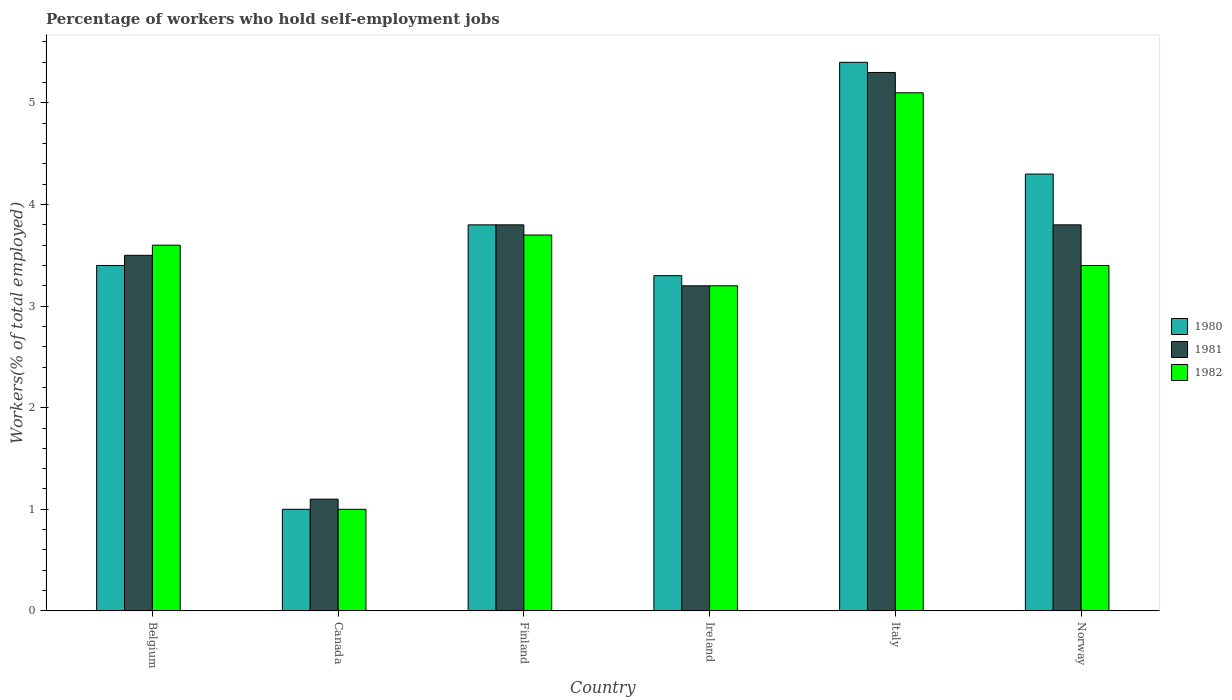How many groups of bars are there?
Ensure brevity in your answer.  6. Are the number of bars on each tick of the X-axis equal?
Your response must be concise. Yes. How many bars are there on the 2nd tick from the left?
Make the answer very short. 3. In how many cases, is the number of bars for a given country not equal to the number of legend labels?
Provide a short and direct response. 0. What is the percentage of self-employed workers in 1980 in Ireland?
Provide a short and direct response. 3.3. Across all countries, what is the maximum percentage of self-employed workers in 1980?
Offer a very short reply. 5.4. Across all countries, what is the minimum percentage of self-employed workers in 1982?
Provide a succinct answer. 1. In which country was the percentage of self-employed workers in 1980 minimum?
Make the answer very short. Canada. What is the total percentage of self-employed workers in 1980 in the graph?
Ensure brevity in your answer.  21.2. What is the difference between the percentage of self-employed workers in 1980 in Canada and that in Ireland?
Provide a succinct answer. -2.3. What is the difference between the percentage of self-employed workers in 1981 in Italy and the percentage of self-employed workers in 1982 in Ireland?
Your answer should be very brief. 2.1. What is the average percentage of self-employed workers in 1981 per country?
Provide a short and direct response. 3.45. What is the ratio of the percentage of self-employed workers in 1980 in Belgium to that in Italy?
Your answer should be very brief. 0.63. What is the difference between the highest and the second highest percentage of self-employed workers in 1982?
Make the answer very short. -0.1. What is the difference between the highest and the lowest percentage of self-employed workers in 1981?
Offer a very short reply. 4.2. In how many countries, is the percentage of self-employed workers in 1980 greater than the average percentage of self-employed workers in 1980 taken over all countries?
Make the answer very short. 3. Is the sum of the percentage of self-employed workers in 1982 in Canada and Finland greater than the maximum percentage of self-employed workers in 1981 across all countries?
Offer a very short reply. No. What does the 2nd bar from the left in Norway represents?
Your answer should be compact. 1981. What is the difference between two consecutive major ticks on the Y-axis?
Provide a succinct answer. 1. Does the graph contain any zero values?
Offer a very short reply. No. What is the title of the graph?
Offer a very short reply. Percentage of workers who hold self-employment jobs. Does "1982" appear as one of the legend labels in the graph?
Keep it short and to the point. Yes. What is the label or title of the X-axis?
Offer a very short reply. Country. What is the label or title of the Y-axis?
Offer a terse response. Workers(% of total employed). What is the Workers(% of total employed) in 1980 in Belgium?
Offer a terse response. 3.4. What is the Workers(% of total employed) of 1982 in Belgium?
Your response must be concise. 3.6. What is the Workers(% of total employed) in 1980 in Canada?
Provide a short and direct response. 1. What is the Workers(% of total employed) in 1981 in Canada?
Provide a succinct answer. 1.1. What is the Workers(% of total employed) in 1980 in Finland?
Provide a short and direct response. 3.8. What is the Workers(% of total employed) of 1981 in Finland?
Make the answer very short. 3.8. What is the Workers(% of total employed) of 1982 in Finland?
Provide a short and direct response. 3.7. What is the Workers(% of total employed) in 1980 in Ireland?
Ensure brevity in your answer.  3.3. What is the Workers(% of total employed) in 1981 in Ireland?
Keep it short and to the point. 3.2. What is the Workers(% of total employed) of 1982 in Ireland?
Your answer should be compact. 3.2. What is the Workers(% of total employed) of 1980 in Italy?
Keep it short and to the point. 5.4. What is the Workers(% of total employed) in 1981 in Italy?
Keep it short and to the point. 5.3. What is the Workers(% of total employed) of 1982 in Italy?
Your answer should be very brief. 5.1. What is the Workers(% of total employed) in 1980 in Norway?
Ensure brevity in your answer.  4.3. What is the Workers(% of total employed) of 1981 in Norway?
Your answer should be very brief. 3.8. What is the Workers(% of total employed) of 1982 in Norway?
Offer a very short reply. 3.4. Across all countries, what is the maximum Workers(% of total employed) of 1980?
Offer a very short reply. 5.4. Across all countries, what is the maximum Workers(% of total employed) in 1981?
Offer a very short reply. 5.3. Across all countries, what is the maximum Workers(% of total employed) in 1982?
Ensure brevity in your answer.  5.1. Across all countries, what is the minimum Workers(% of total employed) in 1981?
Provide a succinct answer. 1.1. Across all countries, what is the minimum Workers(% of total employed) in 1982?
Provide a short and direct response. 1. What is the total Workers(% of total employed) in 1980 in the graph?
Keep it short and to the point. 21.2. What is the total Workers(% of total employed) of 1981 in the graph?
Your response must be concise. 20.7. What is the difference between the Workers(% of total employed) of 1981 in Belgium and that in Finland?
Provide a succinct answer. -0.3. What is the difference between the Workers(% of total employed) in 1982 in Belgium and that in Finland?
Offer a terse response. -0.1. What is the difference between the Workers(% of total employed) in 1980 in Belgium and that in Ireland?
Provide a short and direct response. 0.1. What is the difference between the Workers(% of total employed) of 1981 in Belgium and that in Ireland?
Make the answer very short. 0.3. What is the difference between the Workers(% of total employed) in 1981 in Belgium and that in Italy?
Offer a very short reply. -1.8. What is the difference between the Workers(% of total employed) of 1982 in Belgium and that in Italy?
Provide a succinct answer. -1.5. What is the difference between the Workers(% of total employed) in 1980 in Belgium and that in Norway?
Offer a very short reply. -0.9. What is the difference between the Workers(% of total employed) in 1982 in Belgium and that in Norway?
Offer a terse response. 0.2. What is the difference between the Workers(% of total employed) in 1981 in Canada and that in Finland?
Keep it short and to the point. -2.7. What is the difference between the Workers(% of total employed) in 1982 in Canada and that in Finland?
Ensure brevity in your answer.  -2.7. What is the difference between the Workers(% of total employed) of 1980 in Canada and that in Ireland?
Provide a short and direct response. -2.3. What is the difference between the Workers(% of total employed) in 1981 in Canada and that in Ireland?
Your response must be concise. -2.1. What is the difference between the Workers(% of total employed) of 1981 in Canada and that in Italy?
Provide a succinct answer. -4.2. What is the difference between the Workers(% of total employed) in 1982 in Canada and that in Italy?
Your response must be concise. -4.1. What is the difference between the Workers(% of total employed) of 1981 in Canada and that in Norway?
Your answer should be compact. -2.7. What is the difference between the Workers(% of total employed) of 1982 in Canada and that in Norway?
Your answer should be very brief. -2.4. What is the difference between the Workers(% of total employed) in 1980 in Finland and that in Ireland?
Your response must be concise. 0.5. What is the difference between the Workers(% of total employed) in 1981 in Finland and that in Ireland?
Your answer should be compact. 0.6. What is the difference between the Workers(% of total employed) in 1982 in Finland and that in Ireland?
Make the answer very short. 0.5. What is the difference between the Workers(% of total employed) in 1982 in Finland and that in Italy?
Provide a succinct answer. -1.4. What is the difference between the Workers(% of total employed) of 1980 in Ireland and that in Norway?
Your answer should be compact. -1. What is the difference between the Workers(% of total employed) in 1981 in Ireland and that in Norway?
Keep it short and to the point. -0.6. What is the difference between the Workers(% of total employed) in 1982 in Italy and that in Norway?
Give a very brief answer. 1.7. What is the difference between the Workers(% of total employed) in 1981 in Belgium and the Workers(% of total employed) in 1982 in Canada?
Provide a succinct answer. 2.5. What is the difference between the Workers(% of total employed) of 1980 in Belgium and the Workers(% of total employed) of 1981 in Finland?
Ensure brevity in your answer.  -0.4. What is the difference between the Workers(% of total employed) in 1981 in Belgium and the Workers(% of total employed) in 1982 in Finland?
Your answer should be very brief. -0.2. What is the difference between the Workers(% of total employed) in 1980 in Belgium and the Workers(% of total employed) in 1981 in Ireland?
Offer a very short reply. 0.2. What is the difference between the Workers(% of total employed) of 1980 in Belgium and the Workers(% of total employed) of 1982 in Italy?
Keep it short and to the point. -1.7. What is the difference between the Workers(% of total employed) in 1980 in Belgium and the Workers(% of total employed) in 1982 in Norway?
Provide a short and direct response. 0. What is the difference between the Workers(% of total employed) in 1981 in Belgium and the Workers(% of total employed) in 1982 in Norway?
Your answer should be compact. 0.1. What is the difference between the Workers(% of total employed) of 1980 in Canada and the Workers(% of total employed) of 1981 in Finland?
Keep it short and to the point. -2.8. What is the difference between the Workers(% of total employed) of 1981 in Canada and the Workers(% of total employed) of 1982 in Ireland?
Keep it short and to the point. -2.1. What is the difference between the Workers(% of total employed) of 1980 in Canada and the Workers(% of total employed) of 1981 in Italy?
Provide a short and direct response. -4.3. What is the difference between the Workers(% of total employed) of 1980 in Canada and the Workers(% of total employed) of 1982 in Italy?
Offer a very short reply. -4.1. What is the difference between the Workers(% of total employed) in 1981 in Canada and the Workers(% of total employed) in 1982 in Italy?
Offer a very short reply. -4. What is the difference between the Workers(% of total employed) in 1980 in Canada and the Workers(% of total employed) in 1981 in Norway?
Your answer should be compact. -2.8. What is the difference between the Workers(% of total employed) in 1981 in Canada and the Workers(% of total employed) in 1982 in Norway?
Offer a terse response. -2.3. What is the difference between the Workers(% of total employed) in 1981 in Finland and the Workers(% of total employed) in 1982 in Ireland?
Your response must be concise. 0.6. What is the difference between the Workers(% of total employed) of 1980 in Finland and the Workers(% of total employed) of 1981 in Italy?
Your answer should be very brief. -1.5. What is the difference between the Workers(% of total employed) of 1980 in Finland and the Workers(% of total employed) of 1982 in Italy?
Keep it short and to the point. -1.3. What is the difference between the Workers(% of total employed) in 1981 in Finland and the Workers(% of total employed) in 1982 in Italy?
Provide a succinct answer. -1.3. What is the difference between the Workers(% of total employed) of 1980 in Finland and the Workers(% of total employed) of 1981 in Norway?
Provide a short and direct response. 0. What is the difference between the Workers(% of total employed) of 1980 in Finland and the Workers(% of total employed) of 1982 in Norway?
Your answer should be compact. 0.4. What is the difference between the Workers(% of total employed) of 1980 in Ireland and the Workers(% of total employed) of 1981 in Italy?
Offer a terse response. -2. What is the difference between the Workers(% of total employed) in 1980 in Ireland and the Workers(% of total employed) in 1981 in Norway?
Provide a succinct answer. -0.5. What is the difference between the Workers(% of total employed) in 1980 in Ireland and the Workers(% of total employed) in 1982 in Norway?
Offer a terse response. -0.1. What is the difference between the Workers(% of total employed) in 1980 in Italy and the Workers(% of total employed) in 1981 in Norway?
Provide a short and direct response. 1.6. What is the difference between the Workers(% of total employed) in 1980 in Italy and the Workers(% of total employed) in 1982 in Norway?
Your response must be concise. 2. What is the difference between the Workers(% of total employed) of 1981 in Italy and the Workers(% of total employed) of 1982 in Norway?
Offer a very short reply. 1.9. What is the average Workers(% of total employed) in 1980 per country?
Provide a succinct answer. 3.53. What is the average Workers(% of total employed) in 1981 per country?
Make the answer very short. 3.45. What is the average Workers(% of total employed) of 1982 per country?
Offer a very short reply. 3.33. What is the difference between the Workers(% of total employed) in 1980 and Workers(% of total employed) in 1981 in Belgium?
Offer a terse response. -0.1. What is the difference between the Workers(% of total employed) of 1980 and Workers(% of total employed) of 1982 in Belgium?
Provide a short and direct response. -0.2. What is the difference between the Workers(% of total employed) of 1980 and Workers(% of total employed) of 1981 in Canada?
Provide a short and direct response. -0.1. What is the difference between the Workers(% of total employed) of 1981 and Workers(% of total employed) of 1982 in Canada?
Your response must be concise. 0.1. What is the difference between the Workers(% of total employed) in 1980 and Workers(% of total employed) in 1982 in Finland?
Your answer should be very brief. 0.1. What is the difference between the Workers(% of total employed) in 1981 and Workers(% of total employed) in 1982 in Finland?
Ensure brevity in your answer.  0.1. What is the difference between the Workers(% of total employed) of 1980 and Workers(% of total employed) of 1982 in Ireland?
Your answer should be compact. 0.1. What is the difference between the Workers(% of total employed) of 1981 and Workers(% of total employed) of 1982 in Ireland?
Your answer should be very brief. 0. What is the difference between the Workers(% of total employed) of 1980 and Workers(% of total employed) of 1981 in Italy?
Your answer should be compact. 0.1. What is the difference between the Workers(% of total employed) in 1980 and Workers(% of total employed) in 1981 in Norway?
Your answer should be compact. 0.5. What is the ratio of the Workers(% of total employed) in 1980 in Belgium to that in Canada?
Make the answer very short. 3.4. What is the ratio of the Workers(% of total employed) in 1981 in Belgium to that in Canada?
Provide a succinct answer. 3.18. What is the ratio of the Workers(% of total employed) of 1980 in Belgium to that in Finland?
Provide a succinct answer. 0.89. What is the ratio of the Workers(% of total employed) of 1981 in Belgium to that in Finland?
Ensure brevity in your answer.  0.92. What is the ratio of the Workers(% of total employed) in 1982 in Belgium to that in Finland?
Offer a terse response. 0.97. What is the ratio of the Workers(% of total employed) of 1980 in Belgium to that in Ireland?
Keep it short and to the point. 1.03. What is the ratio of the Workers(% of total employed) in 1981 in Belgium to that in Ireland?
Keep it short and to the point. 1.09. What is the ratio of the Workers(% of total employed) in 1982 in Belgium to that in Ireland?
Your response must be concise. 1.12. What is the ratio of the Workers(% of total employed) of 1980 in Belgium to that in Italy?
Make the answer very short. 0.63. What is the ratio of the Workers(% of total employed) of 1981 in Belgium to that in Italy?
Make the answer very short. 0.66. What is the ratio of the Workers(% of total employed) in 1982 in Belgium to that in Italy?
Provide a short and direct response. 0.71. What is the ratio of the Workers(% of total employed) of 1980 in Belgium to that in Norway?
Offer a terse response. 0.79. What is the ratio of the Workers(% of total employed) of 1981 in Belgium to that in Norway?
Provide a short and direct response. 0.92. What is the ratio of the Workers(% of total employed) of 1982 in Belgium to that in Norway?
Provide a short and direct response. 1.06. What is the ratio of the Workers(% of total employed) in 1980 in Canada to that in Finland?
Your response must be concise. 0.26. What is the ratio of the Workers(% of total employed) of 1981 in Canada to that in Finland?
Ensure brevity in your answer.  0.29. What is the ratio of the Workers(% of total employed) of 1982 in Canada to that in Finland?
Your response must be concise. 0.27. What is the ratio of the Workers(% of total employed) in 1980 in Canada to that in Ireland?
Offer a terse response. 0.3. What is the ratio of the Workers(% of total employed) of 1981 in Canada to that in Ireland?
Your response must be concise. 0.34. What is the ratio of the Workers(% of total employed) of 1982 in Canada to that in Ireland?
Ensure brevity in your answer.  0.31. What is the ratio of the Workers(% of total employed) of 1980 in Canada to that in Italy?
Ensure brevity in your answer.  0.19. What is the ratio of the Workers(% of total employed) of 1981 in Canada to that in Italy?
Offer a very short reply. 0.21. What is the ratio of the Workers(% of total employed) of 1982 in Canada to that in Italy?
Your answer should be compact. 0.2. What is the ratio of the Workers(% of total employed) in 1980 in Canada to that in Norway?
Offer a terse response. 0.23. What is the ratio of the Workers(% of total employed) in 1981 in Canada to that in Norway?
Your response must be concise. 0.29. What is the ratio of the Workers(% of total employed) in 1982 in Canada to that in Norway?
Provide a succinct answer. 0.29. What is the ratio of the Workers(% of total employed) of 1980 in Finland to that in Ireland?
Make the answer very short. 1.15. What is the ratio of the Workers(% of total employed) of 1981 in Finland to that in Ireland?
Your answer should be compact. 1.19. What is the ratio of the Workers(% of total employed) in 1982 in Finland to that in Ireland?
Provide a succinct answer. 1.16. What is the ratio of the Workers(% of total employed) in 1980 in Finland to that in Italy?
Your response must be concise. 0.7. What is the ratio of the Workers(% of total employed) in 1981 in Finland to that in Italy?
Make the answer very short. 0.72. What is the ratio of the Workers(% of total employed) in 1982 in Finland to that in Italy?
Offer a very short reply. 0.73. What is the ratio of the Workers(% of total employed) of 1980 in Finland to that in Norway?
Make the answer very short. 0.88. What is the ratio of the Workers(% of total employed) in 1982 in Finland to that in Norway?
Give a very brief answer. 1.09. What is the ratio of the Workers(% of total employed) in 1980 in Ireland to that in Italy?
Offer a terse response. 0.61. What is the ratio of the Workers(% of total employed) in 1981 in Ireland to that in Italy?
Your response must be concise. 0.6. What is the ratio of the Workers(% of total employed) in 1982 in Ireland to that in Italy?
Ensure brevity in your answer.  0.63. What is the ratio of the Workers(% of total employed) of 1980 in Ireland to that in Norway?
Your response must be concise. 0.77. What is the ratio of the Workers(% of total employed) in 1981 in Ireland to that in Norway?
Give a very brief answer. 0.84. What is the ratio of the Workers(% of total employed) in 1982 in Ireland to that in Norway?
Keep it short and to the point. 0.94. What is the ratio of the Workers(% of total employed) of 1980 in Italy to that in Norway?
Provide a short and direct response. 1.26. What is the ratio of the Workers(% of total employed) in 1981 in Italy to that in Norway?
Offer a terse response. 1.39. What is the difference between the highest and the second highest Workers(% of total employed) of 1981?
Provide a short and direct response. 1.5. What is the difference between the highest and the lowest Workers(% of total employed) in 1980?
Provide a short and direct response. 4.4. What is the difference between the highest and the lowest Workers(% of total employed) of 1981?
Your answer should be compact. 4.2. 